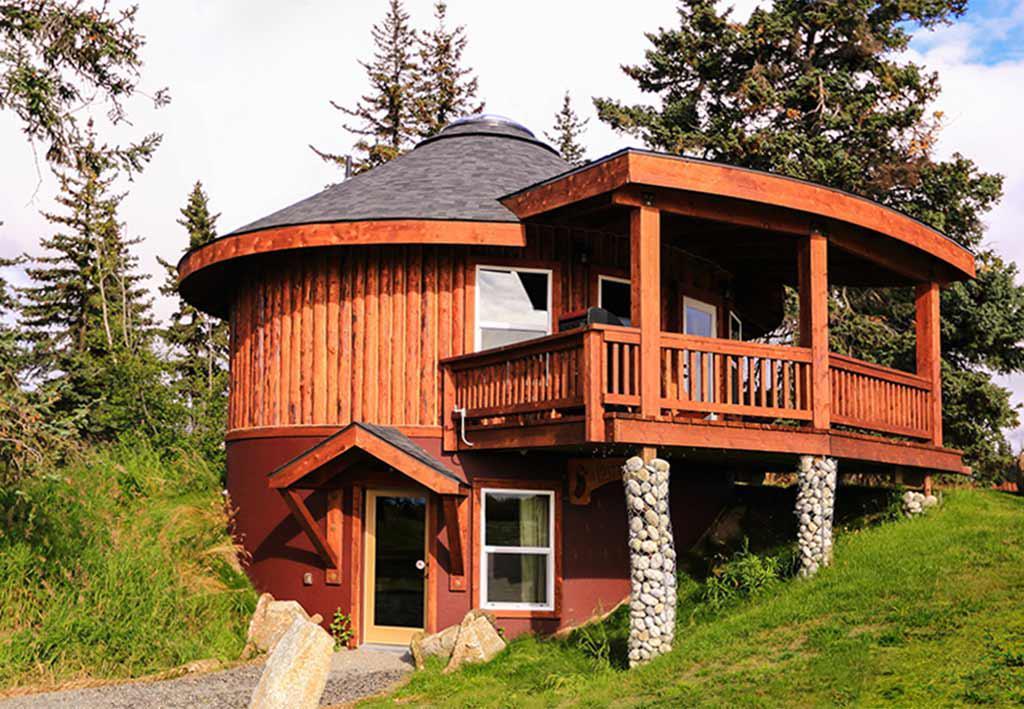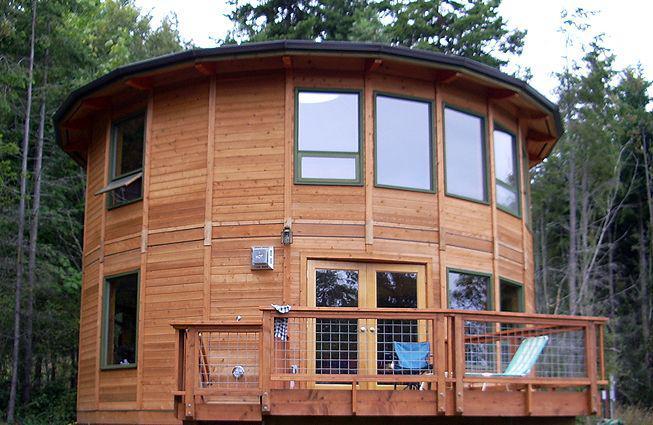The first image is the image on the left, the second image is the image on the right. Analyze the images presented: Is the assertion "At least one image shows a model of a circular building, with a section removed to show the interior." valid? Answer yes or no. No. The first image is the image on the left, the second image is the image on the right. Considering the images on both sides, is "The interior is shown of the hut in at least one of the images." valid? Answer yes or no. No. 